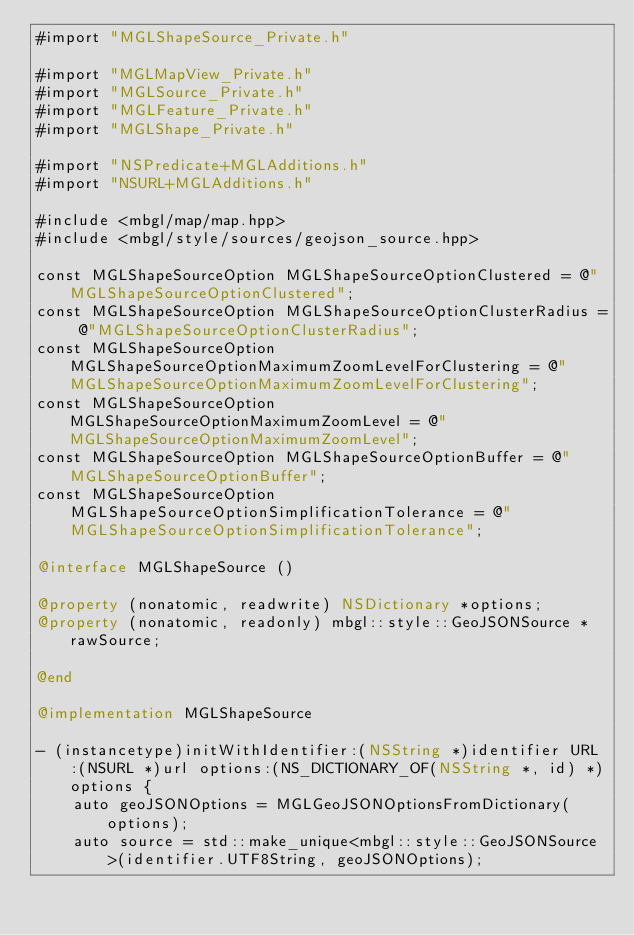<code> <loc_0><loc_0><loc_500><loc_500><_ObjectiveC_>#import "MGLShapeSource_Private.h"

#import "MGLMapView_Private.h"
#import "MGLSource_Private.h"
#import "MGLFeature_Private.h"
#import "MGLShape_Private.h"

#import "NSPredicate+MGLAdditions.h"
#import "NSURL+MGLAdditions.h"

#include <mbgl/map/map.hpp>
#include <mbgl/style/sources/geojson_source.hpp>

const MGLShapeSourceOption MGLShapeSourceOptionClustered = @"MGLShapeSourceOptionClustered";
const MGLShapeSourceOption MGLShapeSourceOptionClusterRadius = @"MGLShapeSourceOptionClusterRadius";
const MGLShapeSourceOption MGLShapeSourceOptionMaximumZoomLevelForClustering = @"MGLShapeSourceOptionMaximumZoomLevelForClustering";
const MGLShapeSourceOption MGLShapeSourceOptionMaximumZoomLevel = @"MGLShapeSourceOptionMaximumZoomLevel";
const MGLShapeSourceOption MGLShapeSourceOptionBuffer = @"MGLShapeSourceOptionBuffer";
const MGLShapeSourceOption MGLShapeSourceOptionSimplificationTolerance = @"MGLShapeSourceOptionSimplificationTolerance";

@interface MGLShapeSource ()

@property (nonatomic, readwrite) NSDictionary *options;
@property (nonatomic, readonly) mbgl::style::GeoJSONSource *rawSource;

@end

@implementation MGLShapeSource

- (instancetype)initWithIdentifier:(NSString *)identifier URL:(NSURL *)url options:(NS_DICTIONARY_OF(NSString *, id) *)options {
    auto geoJSONOptions = MGLGeoJSONOptionsFromDictionary(options);
    auto source = std::make_unique<mbgl::style::GeoJSONSource>(identifier.UTF8String, geoJSONOptions);</code> 